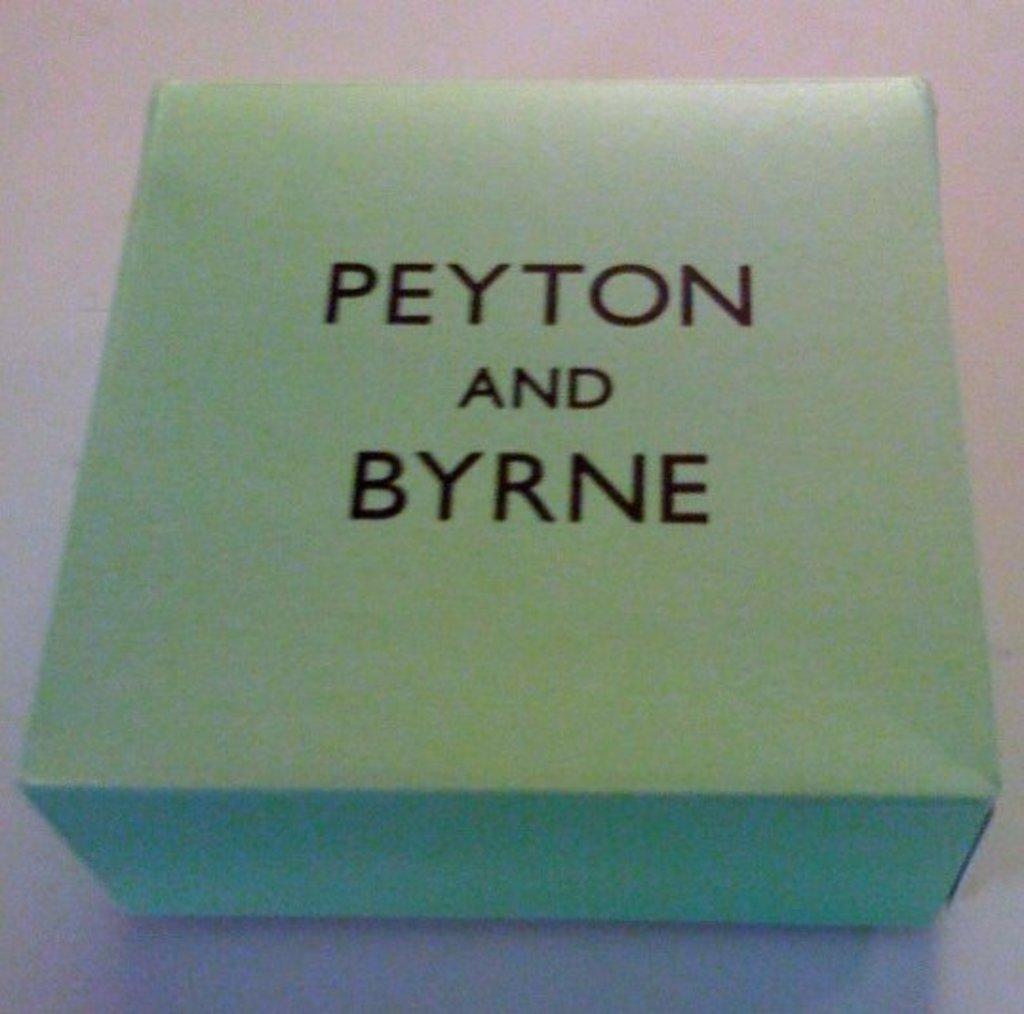Could you give a brief overview of what you see in this image? In this picture, we see a cardboard box in green color. On top of it, it is written as "Peyton and Byrne". In the background, it is white in color. This box might be placed on the white table. 